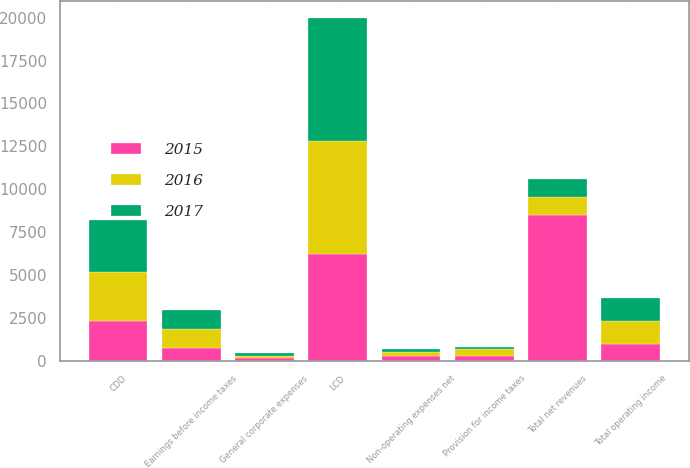<chart> <loc_0><loc_0><loc_500><loc_500><stacked_bar_chart><ecel><fcel>LCD<fcel>CDD<fcel>Total net revenues<fcel>General corporate expenses<fcel>Total operating income<fcel>Non-operating expenses net<fcel>Earnings before income taxes<fcel>Provision for income taxes<nl><fcel>2017<fcel>7170.5<fcel>3037.2<fcel>1051.15<fcel>140.6<fcel>1364.2<fcel>229.3<fcel>1134.9<fcel>139.1<nl><fcel>2016<fcel>6593.9<fcel>2844.1<fcel>1051.15<fcel>147.9<fcel>1312.4<fcel>206.9<fcel>1105.5<fcel>372.3<nl><fcel>2015<fcel>6199.3<fcel>2306.4<fcel>8505.7<fcel>130.4<fcel>996.8<fcel>270.8<fcel>726<fcel>287.3<nl></chart> 